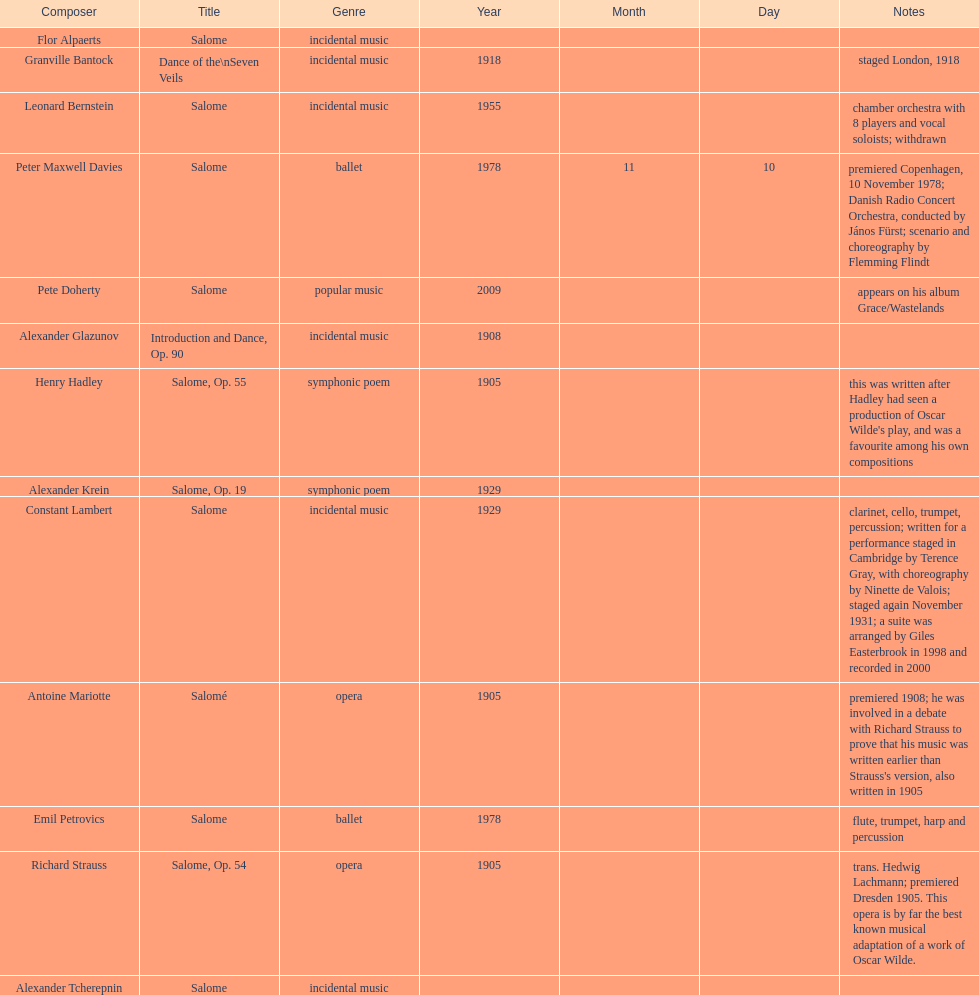Which composer is listed below pete doherty? Alexander Glazunov. 